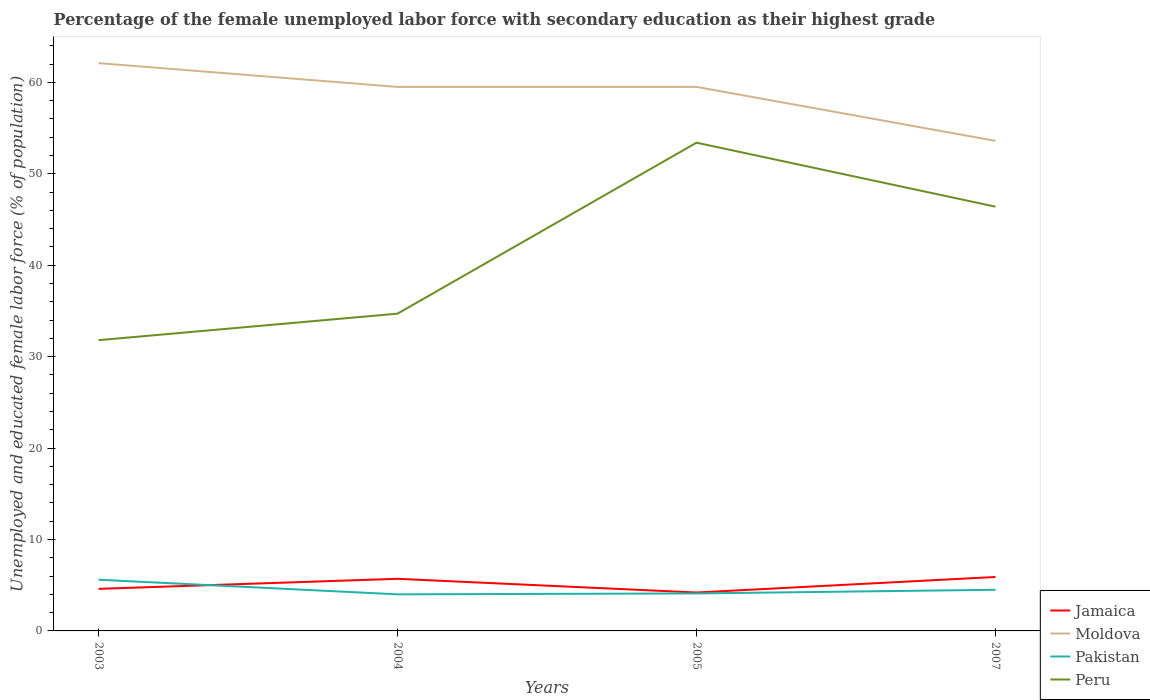How many different coloured lines are there?
Give a very brief answer. 4. Does the line corresponding to Peru intersect with the line corresponding to Moldova?
Keep it short and to the point. No. Is the number of lines equal to the number of legend labels?
Offer a very short reply. Yes. Across all years, what is the maximum percentage of the unemployed female labor force with secondary education in Peru?
Provide a succinct answer. 31.8. In which year was the percentage of the unemployed female labor force with secondary education in Peru maximum?
Offer a very short reply. 2003. What is the total percentage of the unemployed female labor force with secondary education in Moldova in the graph?
Your answer should be compact. 2.6. What is the difference between the highest and the second highest percentage of the unemployed female labor force with secondary education in Peru?
Provide a short and direct response. 21.6. What is the difference between two consecutive major ticks on the Y-axis?
Ensure brevity in your answer.  10. Are the values on the major ticks of Y-axis written in scientific E-notation?
Give a very brief answer. No. Where does the legend appear in the graph?
Provide a short and direct response. Bottom right. What is the title of the graph?
Ensure brevity in your answer.  Percentage of the female unemployed labor force with secondary education as their highest grade. Does "Oman" appear as one of the legend labels in the graph?
Keep it short and to the point. No. What is the label or title of the Y-axis?
Provide a succinct answer. Unemployed and educated female labor force (% of population). What is the Unemployed and educated female labor force (% of population) of Jamaica in 2003?
Offer a very short reply. 4.6. What is the Unemployed and educated female labor force (% of population) in Moldova in 2003?
Offer a very short reply. 62.1. What is the Unemployed and educated female labor force (% of population) in Pakistan in 2003?
Your answer should be very brief. 5.6. What is the Unemployed and educated female labor force (% of population) in Peru in 2003?
Provide a succinct answer. 31.8. What is the Unemployed and educated female labor force (% of population) of Jamaica in 2004?
Provide a short and direct response. 5.7. What is the Unemployed and educated female labor force (% of population) in Moldova in 2004?
Ensure brevity in your answer.  59.5. What is the Unemployed and educated female labor force (% of population) of Peru in 2004?
Offer a terse response. 34.7. What is the Unemployed and educated female labor force (% of population) in Jamaica in 2005?
Offer a terse response. 4.2. What is the Unemployed and educated female labor force (% of population) of Moldova in 2005?
Your answer should be compact. 59.5. What is the Unemployed and educated female labor force (% of population) of Pakistan in 2005?
Offer a very short reply. 4.1. What is the Unemployed and educated female labor force (% of population) in Peru in 2005?
Your answer should be very brief. 53.4. What is the Unemployed and educated female labor force (% of population) of Jamaica in 2007?
Offer a terse response. 5.9. What is the Unemployed and educated female labor force (% of population) of Moldova in 2007?
Offer a terse response. 53.6. What is the Unemployed and educated female labor force (% of population) in Pakistan in 2007?
Keep it short and to the point. 4.5. What is the Unemployed and educated female labor force (% of population) of Peru in 2007?
Offer a very short reply. 46.4. Across all years, what is the maximum Unemployed and educated female labor force (% of population) in Jamaica?
Provide a short and direct response. 5.9. Across all years, what is the maximum Unemployed and educated female labor force (% of population) of Moldova?
Give a very brief answer. 62.1. Across all years, what is the maximum Unemployed and educated female labor force (% of population) of Pakistan?
Your response must be concise. 5.6. Across all years, what is the maximum Unemployed and educated female labor force (% of population) in Peru?
Keep it short and to the point. 53.4. Across all years, what is the minimum Unemployed and educated female labor force (% of population) in Jamaica?
Give a very brief answer. 4.2. Across all years, what is the minimum Unemployed and educated female labor force (% of population) in Moldova?
Offer a very short reply. 53.6. Across all years, what is the minimum Unemployed and educated female labor force (% of population) in Peru?
Your answer should be very brief. 31.8. What is the total Unemployed and educated female labor force (% of population) of Jamaica in the graph?
Offer a very short reply. 20.4. What is the total Unemployed and educated female labor force (% of population) of Moldova in the graph?
Provide a succinct answer. 234.7. What is the total Unemployed and educated female labor force (% of population) of Pakistan in the graph?
Your answer should be compact. 18.2. What is the total Unemployed and educated female labor force (% of population) in Peru in the graph?
Offer a terse response. 166.3. What is the difference between the Unemployed and educated female labor force (% of population) in Moldova in 2003 and that in 2004?
Your answer should be very brief. 2.6. What is the difference between the Unemployed and educated female labor force (% of population) of Peru in 2003 and that in 2004?
Give a very brief answer. -2.9. What is the difference between the Unemployed and educated female labor force (% of population) in Jamaica in 2003 and that in 2005?
Your answer should be compact. 0.4. What is the difference between the Unemployed and educated female labor force (% of population) of Peru in 2003 and that in 2005?
Ensure brevity in your answer.  -21.6. What is the difference between the Unemployed and educated female labor force (% of population) in Pakistan in 2003 and that in 2007?
Make the answer very short. 1.1. What is the difference between the Unemployed and educated female labor force (% of population) of Peru in 2003 and that in 2007?
Offer a terse response. -14.6. What is the difference between the Unemployed and educated female labor force (% of population) of Moldova in 2004 and that in 2005?
Provide a succinct answer. 0. What is the difference between the Unemployed and educated female labor force (% of population) of Pakistan in 2004 and that in 2005?
Your answer should be very brief. -0.1. What is the difference between the Unemployed and educated female labor force (% of population) in Peru in 2004 and that in 2005?
Provide a short and direct response. -18.7. What is the difference between the Unemployed and educated female labor force (% of population) of Jamaica in 2004 and that in 2007?
Offer a very short reply. -0.2. What is the difference between the Unemployed and educated female labor force (% of population) of Peru in 2004 and that in 2007?
Keep it short and to the point. -11.7. What is the difference between the Unemployed and educated female labor force (% of population) in Peru in 2005 and that in 2007?
Provide a succinct answer. 7. What is the difference between the Unemployed and educated female labor force (% of population) of Jamaica in 2003 and the Unemployed and educated female labor force (% of population) of Moldova in 2004?
Keep it short and to the point. -54.9. What is the difference between the Unemployed and educated female labor force (% of population) in Jamaica in 2003 and the Unemployed and educated female labor force (% of population) in Pakistan in 2004?
Keep it short and to the point. 0.6. What is the difference between the Unemployed and educated female labor force (% of population) in Jamaica in 2003 and the Unemployed and educated female labor force (% of population) in Peru in 2004?
Offer a very short reply. -30.1. What is the difference between the Unemployed and educated female labor force (% of population) of Moldova in 2003 and the Unemployed and educated female labor force (% of population) of Pakistan in 2004?
Give a very brief answer. 58.1. What is the difference between the Unemployed and educated female labor force (% of population) of Moldova in 2003 and the Unemployed and educated female labor force (% of population) of Peru in 2004?
Offer a very short reply. 27.4. What is the difference between the Unemployed and educated female labor force (% of population) of Pakistan in 2003 and the Unemployed and educated female labor force (% of population) of Peru in 2004?
Your answer should be very brief. -29.1. What is the difference between the Unemployed and educated female labor force (% of population) of Jamaica in 2003 and the Unemployed and educated female labor force (% of population) of Moldova in 2005?
Give a very brief answer. -54.9. What is the difference between the Unemployed and educated female labor force (% of population) in Jamaica in 2003 and the Unemployed and educated female labor force (% of population) in Peru in 2005?
Ensure brevity in your answer.  -48.8. What is the difference between the Unemployed and educated female labor force (% of population) in Pakistan in 2003 and the Unemployed and educated female labor force (% of population) in Peru in 2005?
Your response must be concise. -47.8. What is the difference between the Unemployed and educated female labor force (% of population) in Jamaica in 2003 and the Unemployed and educated female labor force (% of population) in Moldova in 2007?
Make the answer very short. -49. What is the difference between the Unemployed and educated female labor force (% of population) in Jamaica in 2003 and the Unemployed and educated female labor force (% of population) in Pakistan in 2007?
Make the answer very short. 0.1. What is the difference between the Unemployed and educated female labor force (% of population) of Jamaica in 2003 and the Unemployed and educated female labor force (% of population) of Peru in 2007?
Provide a succinct answer. -41.8. What is the difference between the Unemployed and educated female labor force (% of population) of Moldova in 2003 and the Unemployed and educated female labor force (% of population) of Pakistan in 2007?
Make the answer very short. 57.6. What is the difference between the Unemployed and educated female labor force (% of population) in Moldova in 2003 and the Unemployed and educated female labor force (% of population) in Peru in 2007?
Offer a very short reply. 15.7. What is the difference between the Unemployed and educated female labor force (% of population) of Pakistan in 2003 and the Unemployed and educated female labor force (% of population) of Peru in 2007?
Make the answer very short. -40.8. What is the difference between the Unemployed and educated female labor force (% of population) in Jamaica in 2004 and the Unemployed and educated female labor force (% of population) in Moldova in 2005?
Ensure brevity in your answer.  -53.8. What is the difference between the Unemployed and educated female labor force (% of population) in Jamaica in 2004 and the Unemployed and educated female labor force (% of population) in Pakistan in 2005?
Give a very brief answer. 1.6. What is the difference between the Unemployed and educated female labor force (% of population) of Jamaica in 2004 and the Unemployed and educated female labor force (% of population) of Peru in 2005?
Your answer should be very brief. -47.7. What is the difference between the Unemployed and educated female labor force (% of population) in Moldova in 2004 and the Unemployed and educated female labor force (% of population) in Pakistan in 2005?
Keep it short and to the point. 55.4. What is the difference between the Unemployed and educated female labor force (% of population) in Pakistan in 2004 and the Unemployed and educated female labor force (% of population) in Peru in 2005?
Keep it short and to the point. -49.4. What is the difference between the Unemployed and educated female labor force (% of population) in Jamaica in 2004 and the Unemployed and educated female labor force (% of population) in Moldova in 2007?
Provide a short and direct response. -47.9. What is the difference between the Unemployed and educated female labor force (% of population) of Jamaica in 2004 and the Unemployed and educated female labor force (% of population) of Peru in 2007?
Offer a very short reply. -40.7. What is the difference between the Unemployed and educated female labor force (% of population) of Pakistan in 2004 and the Unemployed and educated female labor force (% of population) of Peru in 2007?
Offer a very short reply. -42.4. What is the difference between the Unemployed and educated female labor force (% of population) of Jamaica in 2005 and the Unemployed and educated female labor force (% of population) of Moldova in 2007?
Offer a very short reply. -49.4. What is the difference between the Unemployed and educated female labor force (% of population) in Jamaica in 2005 and the Unemployed and educated female labor force (% of population) in Pakistan in 2007?
Your answer should be compact. -0.3. What is the difference between the Unemployed and educated female labor force (% of population) in Jamaica in 2005 and the Unemployed and educated female labor force (% of population) in Peru in 2007?
Provide a short and direct response. -42.2. What is the difference between the Unemployed and educated female labor force (% of population) in Moldova in 2005 and the Unemployed and educated female labor force (% of population) in Peru in 2007?
Offer a terse response. 13.1. What is the difference between the Unemployed and educated female labor force (% of population) in Pakistan in 2005 and the Unemployed and educated female labor force (% of population) in Peru in 2007?
Keep it short and to the point. -42.3. What is the average Unemployed and educated female labor force (% of population) of Moldova per year?
Your answer should be compact. 58.67. What is the average Unemployed and educated female labor force (% of population) of Pakistan per year?
Your response must be concise. 4.55. What is the average Unemployed and educated female labor force (% of population) of Peru per year?
Your response must be concise. 41.58. In the year 2003, what is the difference between the Unemployed and educated female labor force (% of population) in Jamaica and Unemployed and educated female labor force (% of population) in Moldova?
Provide a short and direct response. -57.5. In the year 2003, what is the difference between the Unemployed and educated female labor force (% of population) of Jamaica and Unemployed and educated female labor force (% of population) of Pakistan?
Provide a short and direct response. -1. In the year 2003, what is the difference between the Unemployed and educated female labor force (% of population) in Jamaica and Unemployed and educated female labor force (% of population) in Peru?
Provide a short and direct response. -27.2. In the year 2003, what is the difference between the Unemployed and educated female labor force (% of population) of Moldova and Unemployed and educated female labor force (% of population) of Pakistan?
Your response must be concise. 56.5. In the year 2003, what is the difference between the Unemployed and educated female labor force (% of population) in Moldova and Unemployed and educated female labor force (% of population) in Peru?
Your answer should be very brief. 30.3. In the year 2003, what is the difference between the Unemployed and educated female labor force (% of population) in Pakistan and Unemployed and educated female labor force (% of population) in Peru?
Ensure brevity in your answer.  -26.2. In the year 2004, what is the difference between the Unemployed and educated female labor force (% of population) of Jamaica and Unemployed and educated female labor force (% of population) of Moldova?
Provide a short and direct response. -53.8. In the year 2004, what is the difference between the Unemployed and educated female labor force (% of population) in Jamaica and Unemployed and educated female labor force (% of population) in Pakistan?
Provide a succinct answer. 1.7. In the year 2004, what is the difference between the Unemployed and educated female labor force (% of population) of Moldova and Unemployed and educated female labor force (% of population) of Pakistan?
Your response must be concise. 55.5. In the year 2004, what is the difference between the Unemployed and educated female labor force (% of population) of Moldova and Unemployed and educated female labor force (% of population) of Peru?
Give a very brief answer. 24.8. In the year 2004, what is the difference between the Unemployed and educated female labor force (% of population) of Pakistan and Unemployed and educated female labor force (% of population) of Peru?
Offer a very short reply. -30.7. In the year 2005, what is the difference between the Unemployed and educated female labor force (% of population) in Jamaica and Unemployed and educated female labor force (% of population) in Moldova?
Provide a succinct answer. -55.3. In the year 2005, what is the difference between the Unemployed and educated female labor force (% of population) of Jamaica and Unemployed and educated female labor force (% of population) of Pakistan?
Your response must be concise. 0.1. In the year 2005, what is the difference between the Unemployed and educated female labor force (% of population) of Jamaica and Unemployed and educated female labor force (% of population) of Peru?
Your answer should be compact. -49.2. In the year 2005, what is the difference between the Unemployed and educated female labor force (% of population) in Moldova and Unemployed and educated female labor force (% of population) in Pakistan?
Provide a succinct answer. 55.4. In the year 2005, what is the difference between the Unemployed and educated female labor force (% of population) of Pakistan and Unemployed and educated female labor force (% of population) of Peru?
Your answer should be very brief. -49.3. In the year 2007, what is the difference between the Unemployed and educated female labor force (% of population) in Jamaica and Unemployed and educated female labor force (% of population) in Moldova?
Your answer should be very brief. -47.7. In the year 2007, what is the difference between the Unemployed and educated female labor force (% of population) of Jamaica and Unemployed and educated female labor force (% of population) of Peru?
Your response must be concise. -40.5. In the year 2007, what is the difference between the Unemployed and educated female labor force (% of population) of Moldova and Unemployed and educated female labor force (% of population) of Pakistan?
Make the answer very short. 49.1. In the year 2007, what is the difference between the Unemployed and educated female labor force (% of population) in Moldova and Unemployed and educated female labor force (% of population) in Peru?
Your answer should be very brief. 7.2. In the year 2007, what is the difference between the Unemployed and educated female labor force (% of population) of Pakistan and Unemployed and educated female labor force (% of population) of Peru?
Your answer should be very brief. -41.9. What is the ratio of the Unemployed and educated female labor force (% of population) of Jamaica in 2003 to that in 2004?
Provide a succinct answer. 0.81. What is the ratio of the Unemployed and educated female labor force (% of population) of Moldova in 2003 to that in 2004?
Ensure brevity in your answer.  1.04. What is the ratio of the Unemployed and educated female labor force (% of population) in Peru in 2003 to that in 2004?
Give a very brief answer. 0.92. What is the ratio of the Unemployed and educated female labor force (% of population) in Jamaica in 2003 to that in 2005?
Ensure brevity in your answer.  1.1. What is the ratio of the Unemployed and educated female labor force (% of population) of Moldova in 2003 to that in 2005?
Your answer should be compact. 1.04. What is the ratio of the Unemployed and educated female labor force (% of population) of Pakistan in 2003 to that in 2005?
Provide a short and direct response. 1.37. What is the ratio of the Unemployed and educated female labor force (% of population) in Peru in 2003 to that in 2005?
Offer a terse response. 0.6. What is the ratio of the Unemployed and educated female labor force (% of population) in Jamaica in 2003 to that in 2007?
Your answer should be very brief. 0.78. What is the ratio of the Unemployed and educated female labor force (% of population) of Moldova in 2003 to that in 2007?
Your answer should be very brief. 1.16. What is the ratio of the Unemployed and educated female labor force (% of population) of Pakistan in 2003 to that in 2007?
Give a very brief answer. 1.24. What is the ratio of the Unemployed and educated female labor force (% of population) in Peru in 2003 to that in 2007?
Provide a short and direct response. 0.69. What is the ratio of the Unemployed and educated female labor force (% of population) of Jamaica in 2004 to that in 2005?
Offer a terse response. 1.36. What is the ratio of the Unemployed and educated female labor force (% of population) in Pakistan in 2004 to that in 2005?
Make the answer very short. 0.98. What is the ratio of the Unemployed and educated female labor force (% of population) of Peru in 2004 to that in 2005?
Offer a terse response. 0.65. What is the ratio of the Unemployed and educated female labor force (% of population) in Jamaica in 2004 to that in 2007?
Provide a short and direct response. 0.97. What is the ratio of the Unemployed and educated female labor force (% of population) of Moldova in 2004 to that in 2007?
Your answer should be very brief. 1.11. What is the ratio of the Unemployed and educated female labor force (% of population) in Pakistan in 2004 to that in 2007?
Your answer should be very brief. 0.89. What is the ratio of the Unemployed and educated female labor force (% of population) of Peru in 2004 to that in 2007?
Your answer should be very brief. 0.75. What is the ratio of the Unemployed and educated female labor force (% of population) in Jamaica in 2005 to that in 2007?
Ensure brevity in your answer.  0.71. What is the ratio of the Unemployed and educated female labor force (% of population) in Moldova in 2005 to that in 2007?
Give a very brief answer. 1.11. What is the ratio of the Unemployed and educated female labor force (% of population) in Pakistan in 2005 to that in 2007?
Make the answer very short. 0.91. What is the ratio of the Unemployed and educated female labor force (% of population) in Peru in 2005 to that in 2007?
Your answer should be very brief. 1.15. What is the difference between the highest and the second highest Unemployed and educated female labor force (% of population) in Jamaica?
Offer a terse response. 0.2. What is the difference between the highest and the second highest Unemployed and educated female labor force (% of population) of Pakistan?
Your answer should be very brief. 1.1. What is the difference between the highest and the lowest Unemployed and educated female labor force (% of population) in Jamaica?
Your answer should be very brief. 1.7. What is the difference between the highest and the lowest Unemployed and educated female labor force (% of population) in Moldova?
Provide a succinct answer. 8.5. What is the difference between the highest and the lowest Unemployed and educated female labor force (% of population) in Pakistan?
Ensure brevity in your answer.  1.6. What is the difference between the highest and the lowest Unemployed and educated female labor force (% of population) in Peru?
Provide a succinct answer. 21.6. 